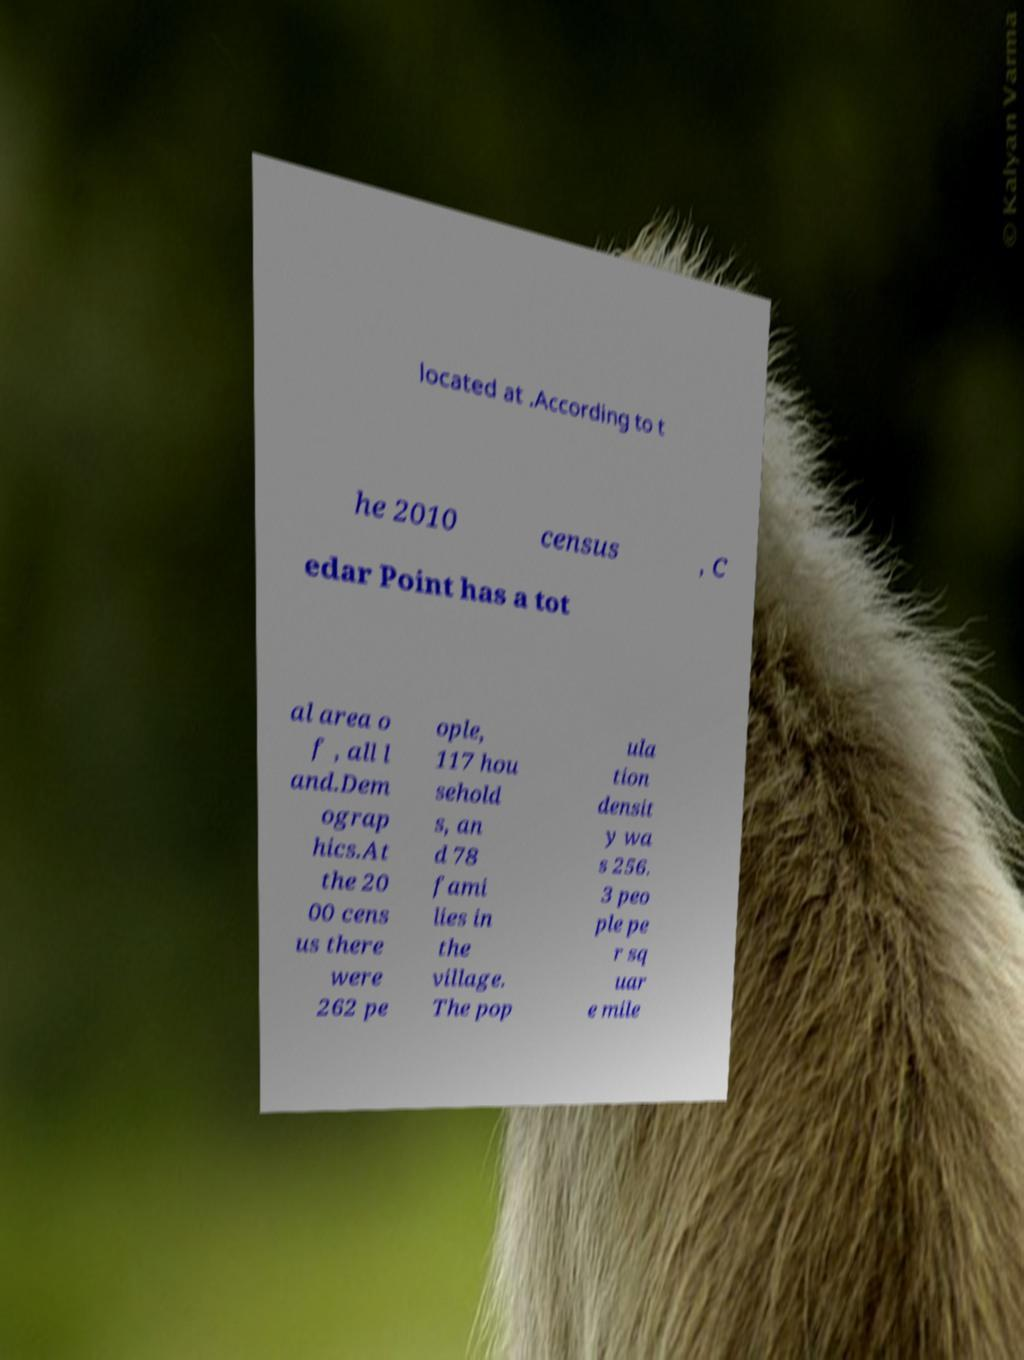Could you assist in decoding the text presented in this image and type it out clearly? located at .According to t he 2010 census , C edar Point has a tot al area o f , all l and.Dem ograp hics.At the 20 00 cens us there were 262 pe ople, 117 hou sehold s, an d 78 fami lies in the village. The pop ula tion densit y wa s 256. 3 peo ple pe r sq uar e mile 